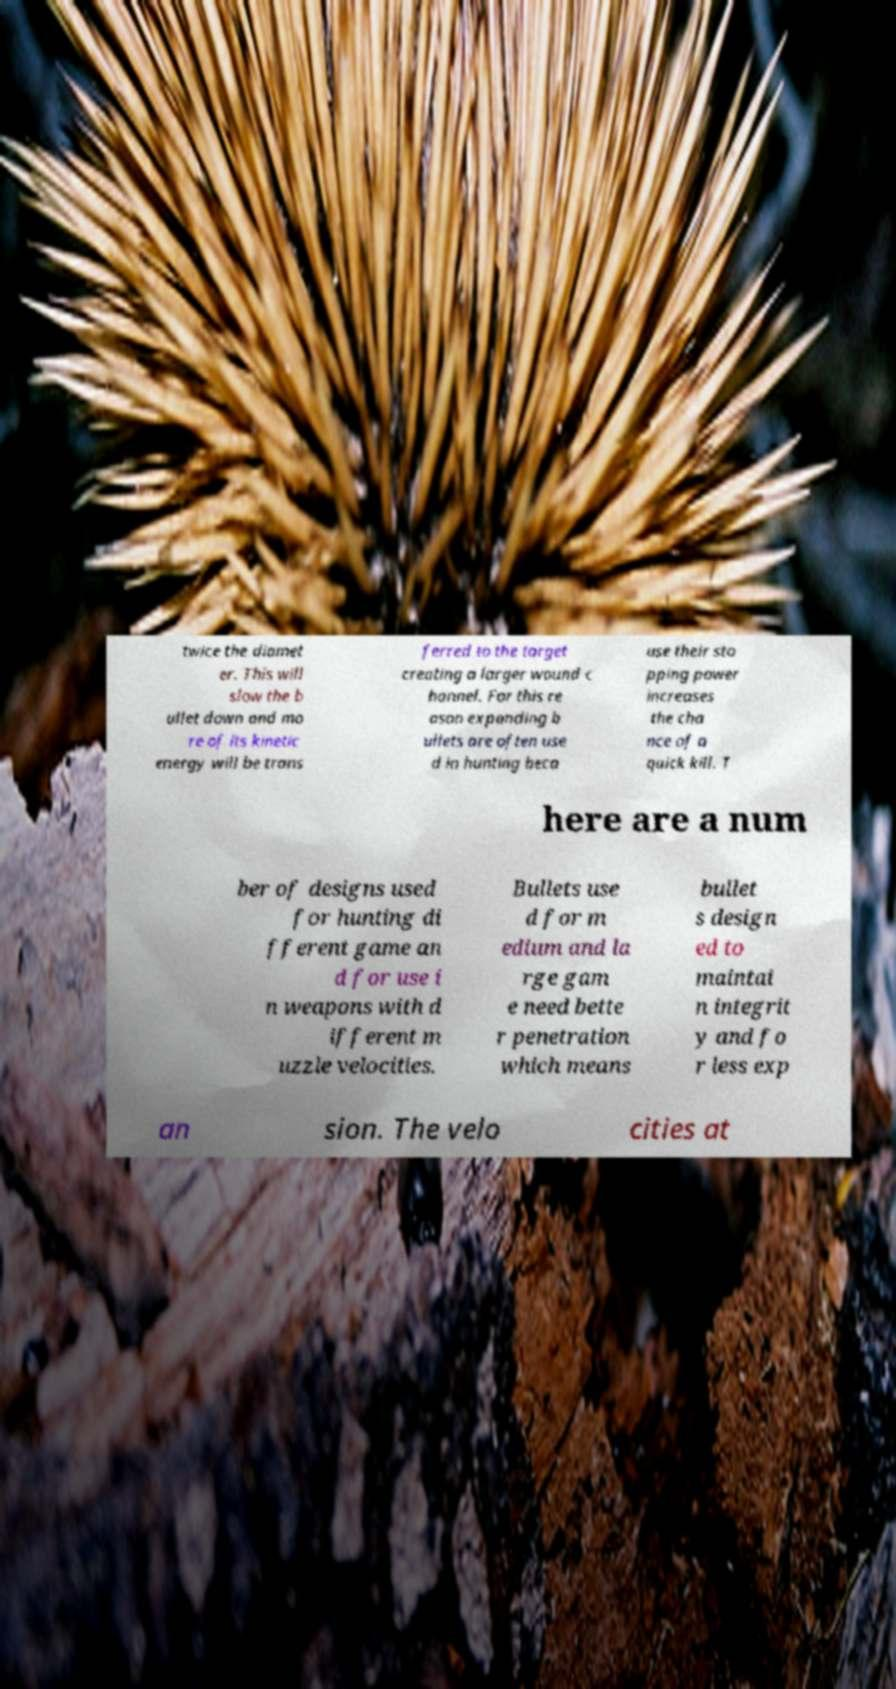Please read and relay the text visible in this image. What does it say? twice the diamet er. This will slow the b ullet down and mo re of its kinetic energy will be trans ferred to the target creating a larger wound c hannel. For this re ason expanding b ullets are often use d in hunting beca use their sto pping power increases the cha nce of a quick kill. T here are a num ber of designs used for hunting di fferent game an d for use i n weapons with d ifferent m uzzle velocities. Bullets use d for m edium and la rge gam e need bette r penetration which means bullet s design ed to maintai n integrit y and fo r less exp an sion. The velo cities at 